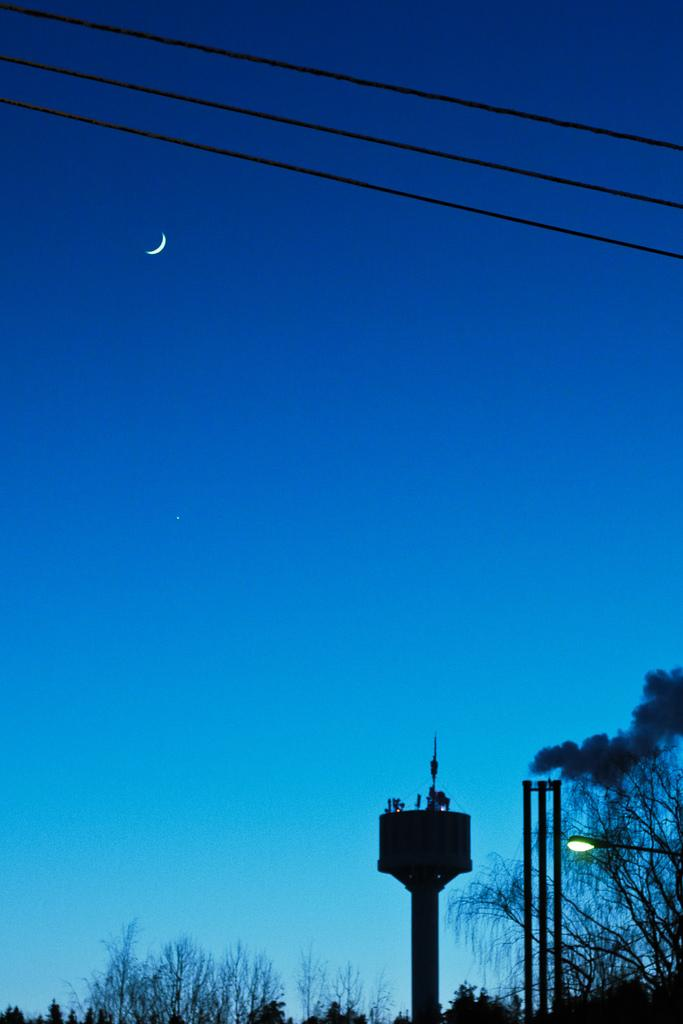What type of natural elements can be seen in the image? There are trees in the image. What man-made structures are present in the image? There are poles in the image. What is located in the foreground of the image? There is a light in the foreground of the image. What is present at the top of the image? There are wires at the top of the image. What celestial body is visible in the sky? The moon is visible in the sky. What type of waves can be seen crashing against the shore in the image? There is no shore or waves present in the image; it features trees, poles, a light, wires, and the moon. How many chickens are visible in the image? There are no chickens present in the image. 